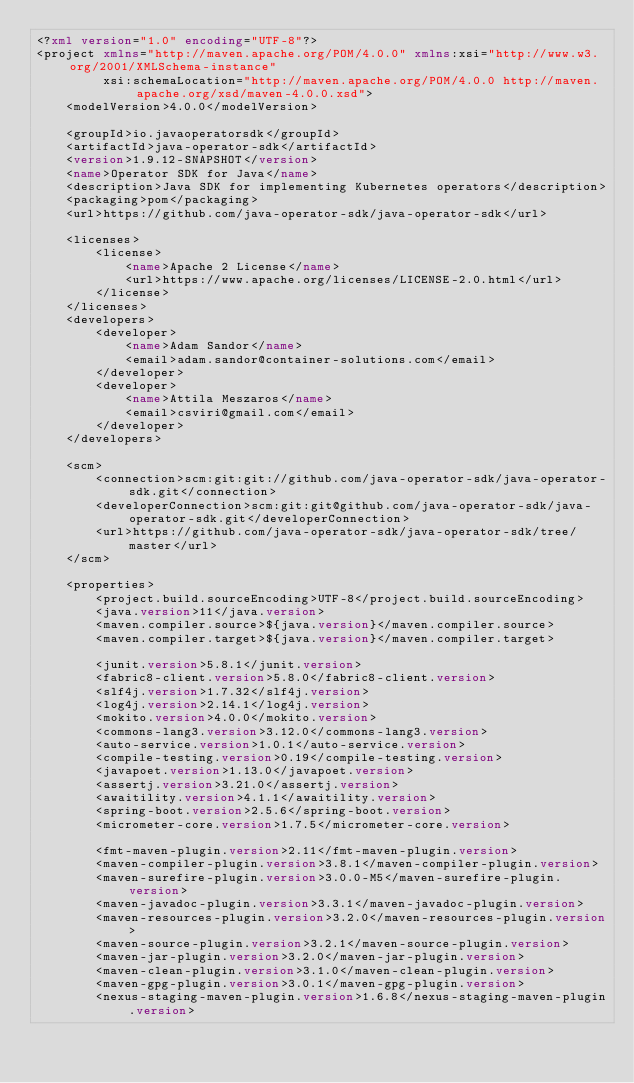<code> <loc_0><loc_0><loc_500><loc_500><_XML_><?xml version="1.0" encoding="UTF-8"?>
<project xmlns="http://maven.apache.org/POM/4.0.0" xmlns:xsi="http://www.w3.org/2001/XMLSchema-instance"
         xsi:schemaLocation="http://maven.apache.org/POM/4.0.0 http://maven.apache.org/xsd/maven-4.0.0.xsd">
    <modelVersion>4.0.0</modelVersion>

    <groupId>io.javaoperatorsdk</groupId>
    <artifactId>java-operator-sdk</artifactId>
    <version>1.9.12-SNAPSHOT</version>
    <name>Operator SDK for Java</name>
    <description>Java SDK for implementing Kubernetes operators</description>
    <packaging>pom</packaging>
    <url>https://github.com/java-operator-sdk/java-operator-sdk</url>

    <licenses>
        <license>
            <name>Apache 2 License</name>
            <url>https://www.apache.org/licenses/LICENSE-2.0.html</url>
        </license>
    </licenses>
    <developers>
        <developer>
            <name>Adam Sandor</name>
            <email>adam.sandor@container-solutions.com</email>
        </developer>
        <developer>
            <name>Attila Meszaros</name>
            <email>csviri@gmail.com</email>
        </developer>
    </developers>

    <scm>
        <connection>scm:git:git://github.com/java-operator-sdk/java-operator-sdk.git</connection>
        <developerConnection>scm:git:git@github.com/java-operator-sdk/java-operator-sdk.git</developerConnection>
        <url>https://github.com/java-operator-sdk/java-operator-sdk/tree/master</url>
    </scm>

    <properties>
        <project.build.sourceEncoding>UTF-8</project.build.sourceEncoding>
        <java.version>11</java.version>
        <maven.compiler.source>${java.version}</maven.compiler.source>
        <maven.compiler.target>${java.version}</maven.compiler.target>

        <junit.version>5.8.1</junit.version>
        <fabric8-client.version>5.8.0</fabric8-client.version>
        <slf4j.version>1.7.32</slf4j.version>
        <log4j.version>2.14.1</log4j.version>
        <mokito.version>4.0.0</mokito.version>
        <commons-lang3.version>3.12.0</commons-lang3.version>
        <auto-service.version>1.0.1</auto-service.version>
        <compile-testing.version>0.19</compile-testing.version>
        <javapoet.version>1.13.0</javapoet.version>
        <assertj.version>3.21.0</assertj.version>
        <awaitility.version>4.1.1</awaitility.version>
        <spring-boot.version>2.5.6</spring-boot.version>
        <micrometer-core.version>1.7.5</micrometer-core.version>

        <fmt-maven-plugin.version>2.11</fmt-maven-plugin.version>
        <maven-compiler-plugin.version>3.8.1</maven-compiler-plugin.version>
        <maven-surefire-plugin.version>3.0.0-M5</maven-surefire-plugin.version>
        <maven-javadoc-plugin.version>3.3.1</maven-javadoc-plugin.version>
        <maven-resources-plugin.version>3.2.0</maven-resources-plugin.version>
        <maven-source-plugin.version>3.2.1</maven-source-plugin.version>
        <maven-jar-plugin.version>3.2.0</maven-jar-plugin.version>
        <maven-clean-plugin.version>3.1.0</maven-clean-plugin.version>
        <maven-gpg-plugin.version>3.0.1</maven-gpg-plugin.version>
        <nexus-staging-maven-plugin.version>1.6.8</nexus-staging-maven-plugin.version></code> 